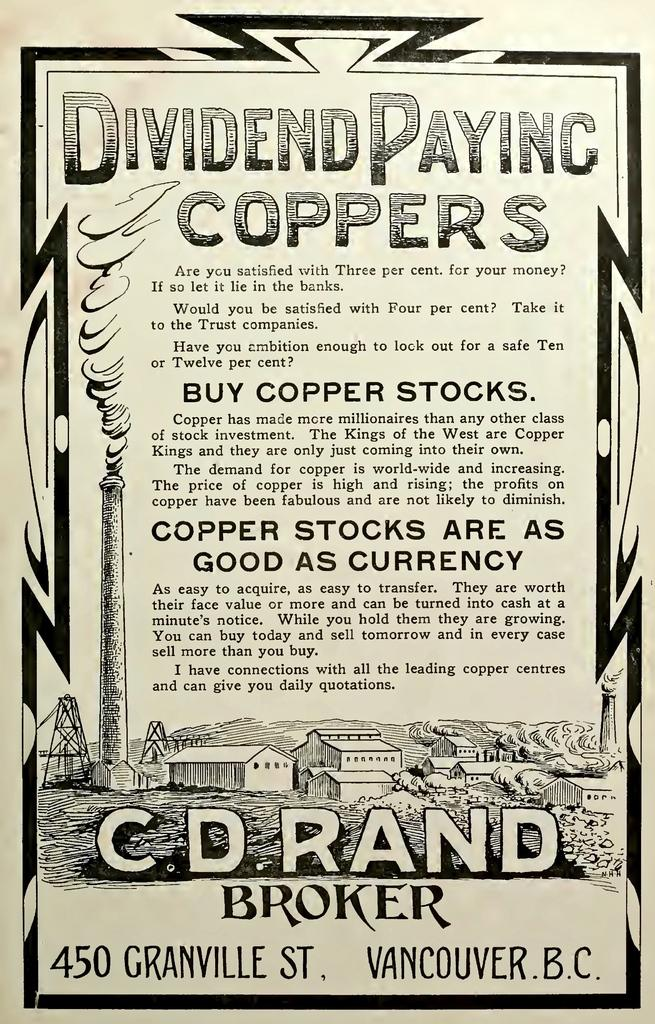<image>
Share a concise interpretation of the image provided. A flyer advertising Dividend Paying Coppers from C.D. Rand Broker 